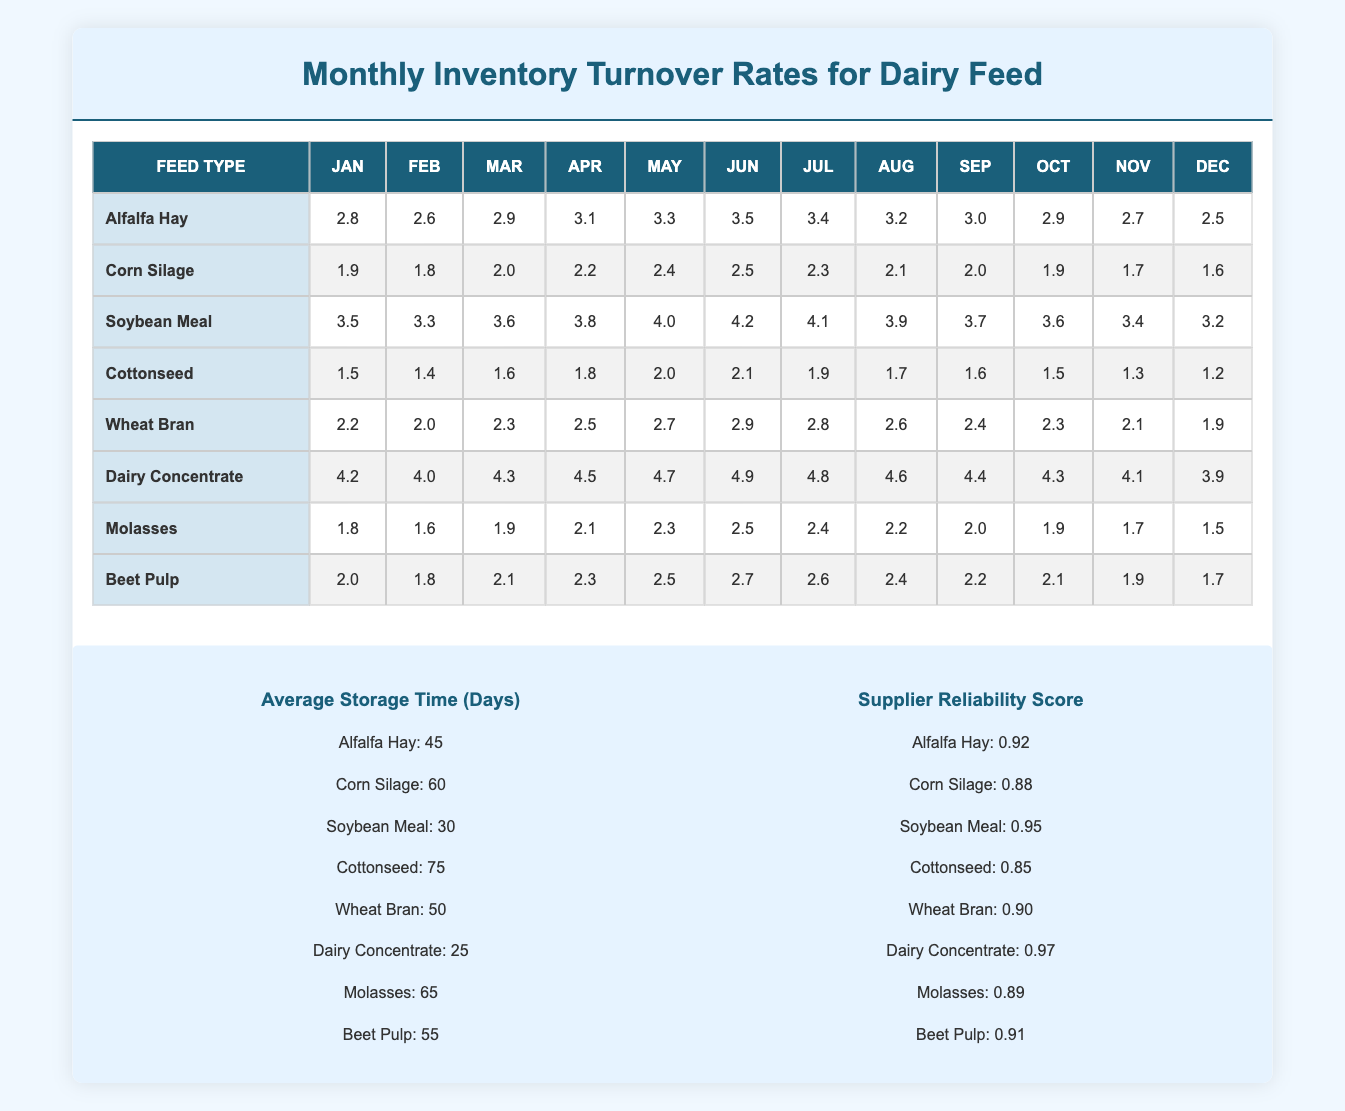What is the highest inventory turnover rate for Dairy Concentrate? The highest inventory turnover rate for Dairy Concentrate is found in June, where it is recorded at 4.9.
Answer: 4.9 Which feed type has the lowest average inventory turnover rate? The feed type with the lowest average inventory turnover rate is Cottonseed, which has an average rate of 1.5 over the months.
Answer: Cottonseed What is the average inventory turnover rate for Alfalfa Hay from January to December? To find the average rate, sum the monthly turnover rates for Alfalfa Hay (2.8 + 2.6 + 2.9 + 3.1 + 3.3 + 3.5 + 3.4 + 3.2 + 3.0 + 2.9 + 2.7 + 2.5 = 37.9) and divide by the number of months (12), which gives 37.9 / 12 = 3.1583.
Answer: 3.16 Does Soybean Meal have a higher turnover rate than Wheat Bran in April? In April, Soybean Meal has a turnover rate of 3.8, while Wheat Bran has 2.5, therefore Soybean Meal has a higher rate.
Answer: Yes What is the total turnover rate for Corn Silage from January to June? To calculate the total turnover, sum the monthly rates from January to June: (1.9 + 1.8 + 2.0 + 2.2 + 2.4 + 2.5 = 12.0). The total turnover rate for those months equals 12.0.
Answer: 12.0 What is the difference in the average inventory turnover rates between Dairy Concentrate and Molasses? First, calculate the average for both: Dairy Concentrate (4.2 + 4.0 + 4.3 + 4.5 + 4.7 + 4.9 + 4.8 + 4.6 + 4.4 + 4.3 + 4.1 + 3.9 = 54.5, divided by 12 = 4.5417) and Molasses (1.8 + 1.6 + 1.9 + 2.1 + 2.3 + 2.5 + 2.4 + 2.2 + 2.0 + 1.9 + 1.7 + 1.5 = 24.0, divided by 12 = 2.0). The difference is 4.5417 - 2.0 = 2.5417.
Answer: 2.54 Which feed type has a supplier reliability score of 0.97? The feed type with a supplier reliability score of 0.97 is Dairy Concentrate.
Answer: Dairy Concentrate Is the average storage time for Cottonseed longer than for Soybean Meal? Cottonseed has an average storage time of 75 days and Soybean Meal has 30 days, therefore yes, the average storage time for Cottonseed is longer.
Answer: Yes In which month did Alfalfa Hay exhibit its highest turnover rate? Alfalfa Hay exhibited its highest turnover rate in June with a value of 3.5.
Answer: June 